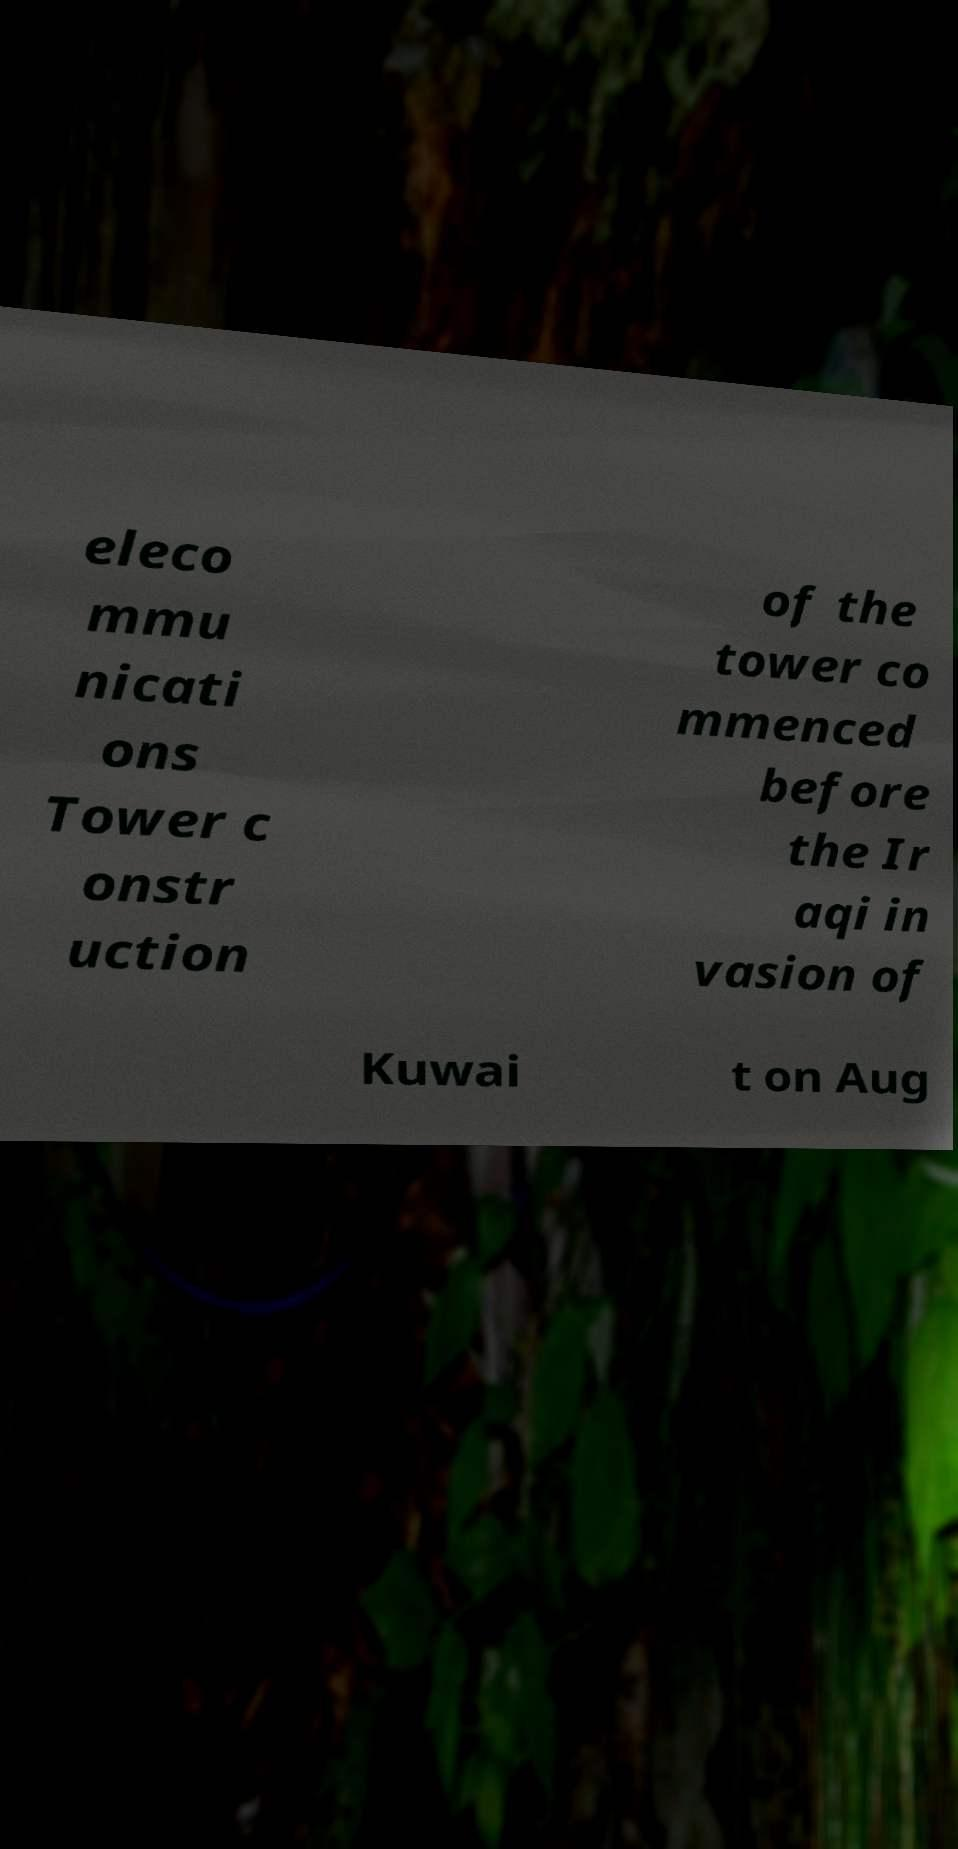What messages or text are displayed in this image? I need them in a readable, typed format. eleco mmu nicati ons Tower c onstr uction of the tower co mmenced before the Ir aqi in vasion of Kuwai t on Aug 